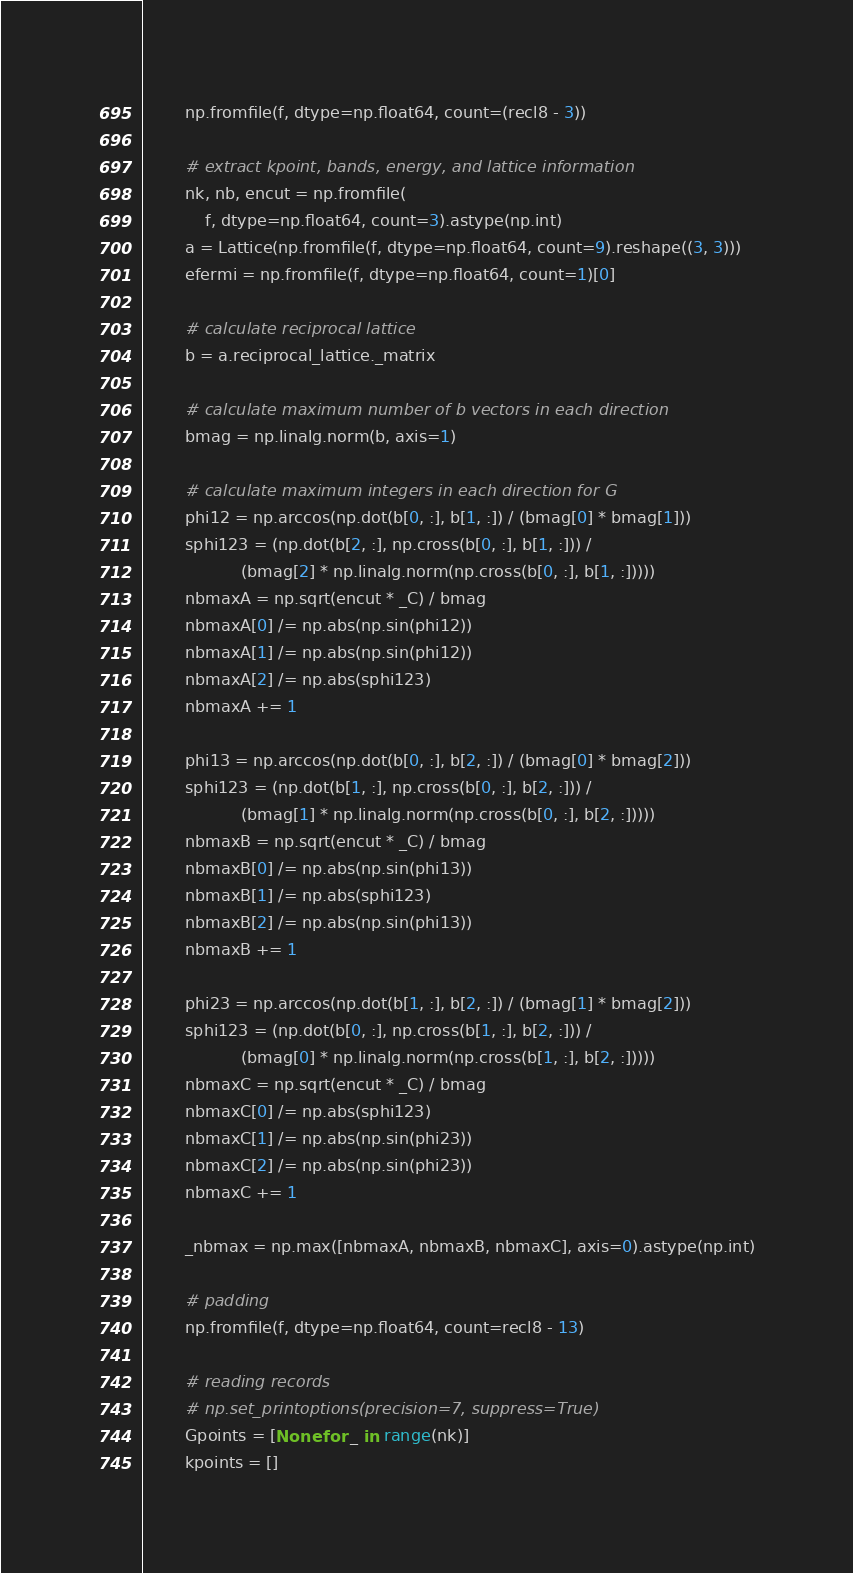Convert code to text. <code><loc_0><loc_0><loc_500><loc_500><_Python_>        np.fromfile(f, dtype=np.float64, count=(recl8 - 3))

        # extract kpoint, bands, energy, and lattice information
        nk, nb, encut = np.fromfile(
            f, dtype=np.float64, count=3).astype(np.int)
        a = Lattice(np.fromfile(f, dtype=np.float64, count=9).reshape((3, 3)))
        efermi = np.fromfile(f, dtype=np.float64, count=1)[0]

        # calculate reciprocal lattice
        b = a.reciprocal_lattice._matrix

        # calculate maximum number of b vectors in each direction
        bmag = np.linalg.norm(b, axis=1)

        # calculate maximum integers in each direction for G
        phi12 = np.arccos(np.dot(b[0, :], b[1, :]) / (bmag[0] * bmag[1]))
        sphi123 = (np.dot(b[2, :], np.cross(b[0, :], b[1, :])) /
                   (bmag[2] * np.linalg.norm(np.cross(b[0, :], b[1, :]))))
        nbmaxA = np.sqrt(encut * _C) / bmag
        nbmaxA[0] /= np.abs(np.sin(phi12))
        nbmaxA[1] /= np.abs(np.sin(phi12))
        nbmaxA[2] /= np.abs(sphi123)
        nbmaxA += 1

        phi13 = np.arccos(np.dot(b[0, :], b[2, :]) / (bmag[0] * bmag[2]))
        sphi123 = (np.dot(b[1, :], np.cross(b[0, :], b[2, :])) /
                   (bmag[1] * np.linalg.norm(np.cross(b[0, :], b[2, :]))))
        nbmaxB = np.sqrt(encut * _C) / bmag
        nbmaxB[0] /= np.abs(np.sin(phi13))
        nbmaxB[1] /= np.abs(sphi123)
        nbmaxB[2] /= np.abs(np.sin(phi13))
        nbmaxB += 1

        phi23 = np.arccos(np.dot(b[1, :], b[2, :]) / (bmag[1] * bmag[2]))
        sphi123 = (np.dot(b[0, :], np.cross(b[1, :], b[2, :])) /
                   (bmag[0] * np.linalg.norm(np.cross(b[1, :], b[2, :]))))
        nbmaxC = np.sqrt(encut * _C) / bmag
        nbmaxC[0] /= np.abs(sphi123)
        nbmaxC[1] /= np.abs(np.sin(phi23))
        nbmaxC[2] /= np.abs(np.sin(phi23))
        nbmaxC += 1

        _nbmax = np.max([nbmaxA, nbmaxB, nbmaxC], axis=0).astype(np.int)

        # padding
        np.fromfile(f, dtype=np.float64, count=recl8 - 13)

        # reading records
        # np.set_printoptions(precision=7, suppress=True)
        Gpoints = [None for _ in range(nk)]
        kpoints = []</code> 